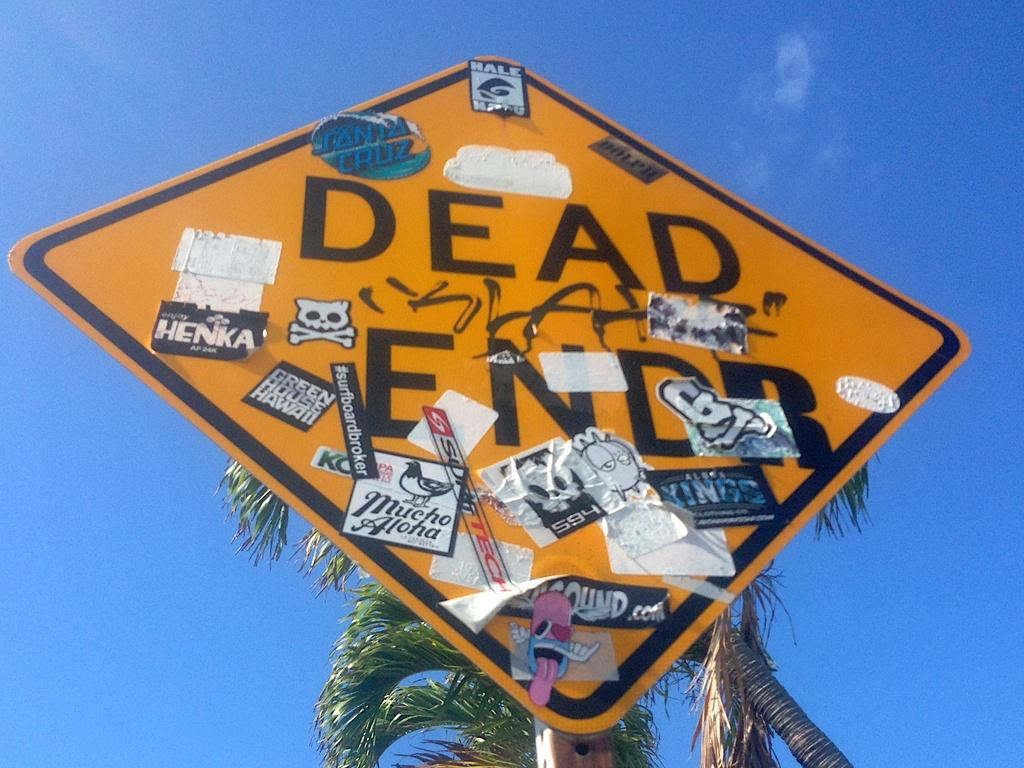<image>
Present a compact description of the photo's key features. A dead end sign is covered in different stickers. 